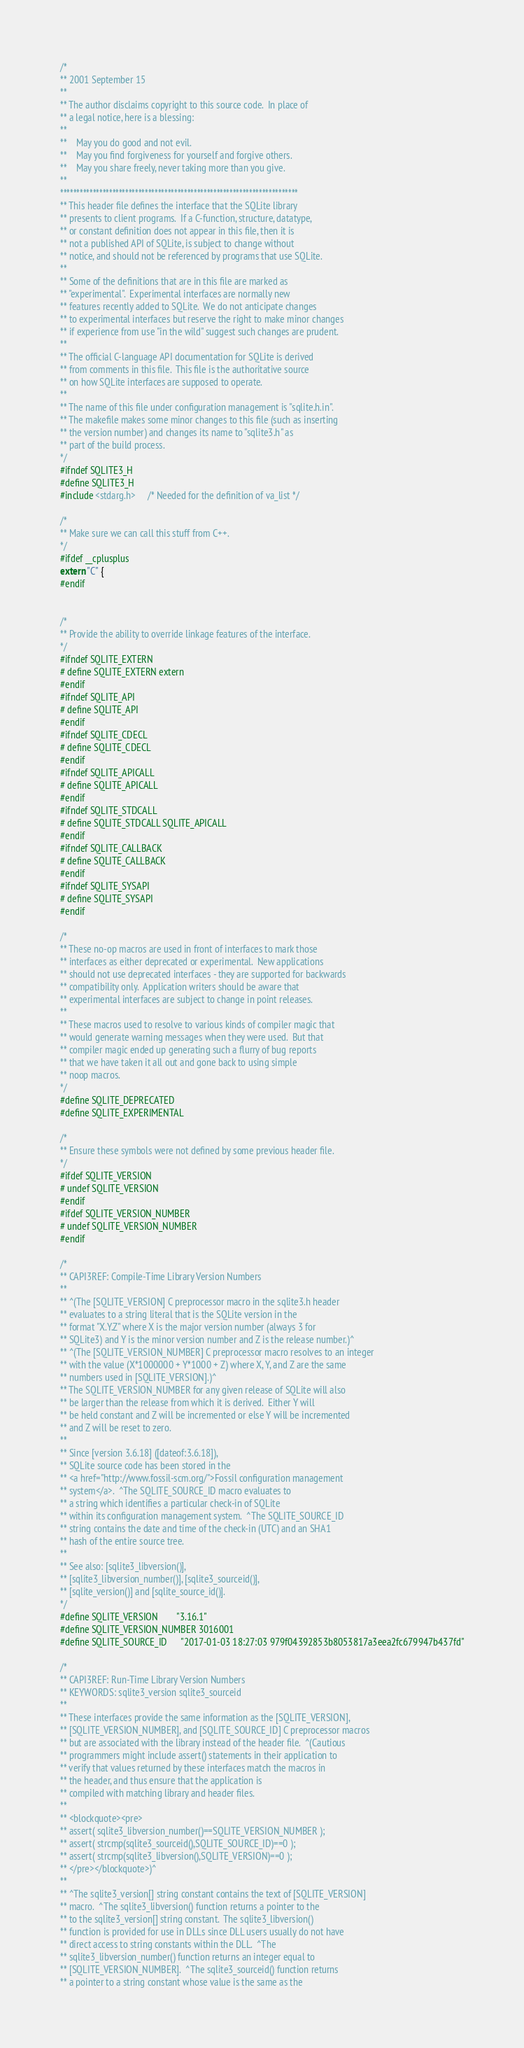Convert code to text. <code><loc_0><loc_0><loc_500><loc_500><_C_>/*
** 2001 September 15
**
** The author disclaims copyright to this source code.  In place of
** a legal notice, here is a blessing:
**
**    May you do good and not evil.
**    May you find forgiveness for yourself and forgive others.
**    May you share freely, never taking more than you give.
**
*************************************************************************
** This header file defines the interface that the SQLite library
** presents to client programs.  If a C-function, structure, datatype,
** or constant definition does not appear in this file, then it is
** not a published API of SQLite, is subject to change without
** notice, and should not be referenced by programs that use SQLite.
**
** Some of the definitions that are in this file are marked as
** "experimental".  Experimental interfaces are normally new
** features recently added to SQLite.  We do not anticipate changes
** to experimental interfaces but reserve the right to make minor changes
** if experience from use "in the wild" suggest such changes are prudent.
**
** The official C-language API documentation for SQLite is derived
** from comments in this file.  This file is the authoritative source
** on how SQLite interfaces are supposed to operate.
**
** The name of this file under configuration management is "sqlite.h.in".
** The makefile makes some minor changes to this file (such as inserting
** the version number) and changes its name to "sqlite3.h" as
** part of the build process.
*/
#ifndef SQLITE3_H
#define SQLITE3_H
#include <stdarg.h>     /* Needed for the definition of va_list */

/*
** Make sure we can call this stuff from C++.
*/
#ifdef __cplusplus
extern "C" {
#endif


/*
** Provide the ability to override linkage features of the interface.
*/
#ifndef SQLITE_EXTERN
# define SQLITE_EXTERN extern
#endif
#ifndef SQLITE_API
# define SQLITE_API
#endif
#ifndef SQLITE_CDECL
# define SQLITE_CDECL
#endif
#ifndef SQLITE_APICALL
# define SQLITE_APICALL
#endif
#ifndef SQLITE_STDCALL
# define SQLITE_STDCALL SQLITE_APICALL
#endif
#ifndef SQLITE_CALLBACK
# define SQLITE_CALLBACK
#endif
#ifndef SQLITE_SYSAPI
# define SQLITE_SYSAPI
#endif

/*
** These no-op macros are used in front of interfaces to mark those
** interfaces as either deprecated or experimental.  New applications
** should not use deprecated interfaces - they are supported for backwards
** compatibility only.  Application writers should be aware that
** experimental interfaces are subject to change in point releases.
**
** These macros used to resolve to various kinds of compiler magic that
** would generate warning messages when they were used.  But that
** compiler magic ended up generating such a flurry of bug reports
** that we have taken it all out and gone back to using simple
** noop macros.
*/
#define SQLITE_DEPRECATED
#define SQLITE_EXPERIMENTAL

/*
** Ensure these symbols were not defined by some previous header file.
*/
#ifdef SQLITE_VERSION
# undef SQLITE_VERSION
#endif
#ifdef SQLITE_VERSION_NUMBER
# undef SQLITE_VERSION_NUMBER
#endif

/*
** CAPI3REF: Compile-Time Library Version Numbers
**
** ^(The [SQLITE_VERSION] C preprocessor macro in the sqlite3.h header
** evaluates to a string literal that is the SQLite version in the
** format "X.Y.Z" where X is the major version number (always 3 for
** SQLite3) and Y is the minor version number and Z is the release number.)^
** ^(The [SQLITE_VERSION_NUMBER] C preprocessor macro resolves to an integer
** with the value (X*1000000 + Y*1000 + Z) where X, Y, and Z are the same
** numbers used in [SQLITE_VERSION].)^
** The SQLITE_VERSION_NUMBER for any given release of SQLite will also
** be larger than the release from which it is derived.  Either Y will
** be held constant and Z will be incremented or else Y will be incremented
** and Z will be reset to zero.
**
** Since [version 3.6.18] ([dateof:3.6.18]), 
** SQLite source code has been stored in the
** <a href="http://www.fossil-scm.org/">Fossil configuration management
** system</a>.  ^The SQLITE_SOURCE_ID macro evaluates to
** a string which identifies a particular check-in of SQLite
** within its configuration management system.  ^The SQLITE_SOURCE_ID
** string contains the date and time of the check-in (UTC) and an SHA1
** hash of the entire source tree.
**
** See also: [sqlite3_libversion()],
** [sqlite3_libversion_number()], [sqlite3_sourceid()],
** [sqlite_version()] and [sqlite_source_id()].
*/
#define SQLITE_VERSION        "3.16.1"
#define SQLITE_VERSION_NUMBER 3016001
#define SQLITE_SOURCE_ID      "2017-01-03 18:27:03 979f04392853b8053817a3eea2fc679947b437fd"

/*
** CAPI3REF: Run-Time Library Version Numbers
** KEYWORDS: sqlite3_version sqlite3_sourceid
**
** These interfaces provide the same information as the [SQLITE_VERSION],
** [SQLITE_VERSION_NUMBER], and [SQLITE_SOURCE_ID] C preprocessor macros
** but are associated with the library instead of the header file.  ^(Cautious
** programmers might include assert() statements in their application to
** verify that values returned by these interfaces match the macros in
** the header, and thus ensure that the application is
** compiled with matching library and header files.
**
** <blockquote><pre>
** assert( sqlite3_libversion_number()==SQLITE_VERSION_NUMBER );
** assert( strcmp(sqlite3_sourceid(),SQLITE_SOURCE_ID)==0 );
** assert( strcmp(sqlite3_libversion(),SQLITE_VERSION)==0 );
** </pre></blockquote>)^
**
** ^The sqlite3_version[] string constant contains the text of [SQLITE_VERSION]
** macro.  ^The sqlite3_libversion() function returns a pointer to the
** to the sqlite3_version[] string constant.  The sqlite3_libversion()
** function is provided for use in DLLs since DLL users usually do not have
** direct access to string constants within the DLL.  ^The
** sqlite3_libversion_number() function returns an integer equal to
** [SQLITE_VERSION_NUMBER].  ^The sqlite3_sourceid() function returns 
** a pointer to a string constant whose value is the same as the </code> 